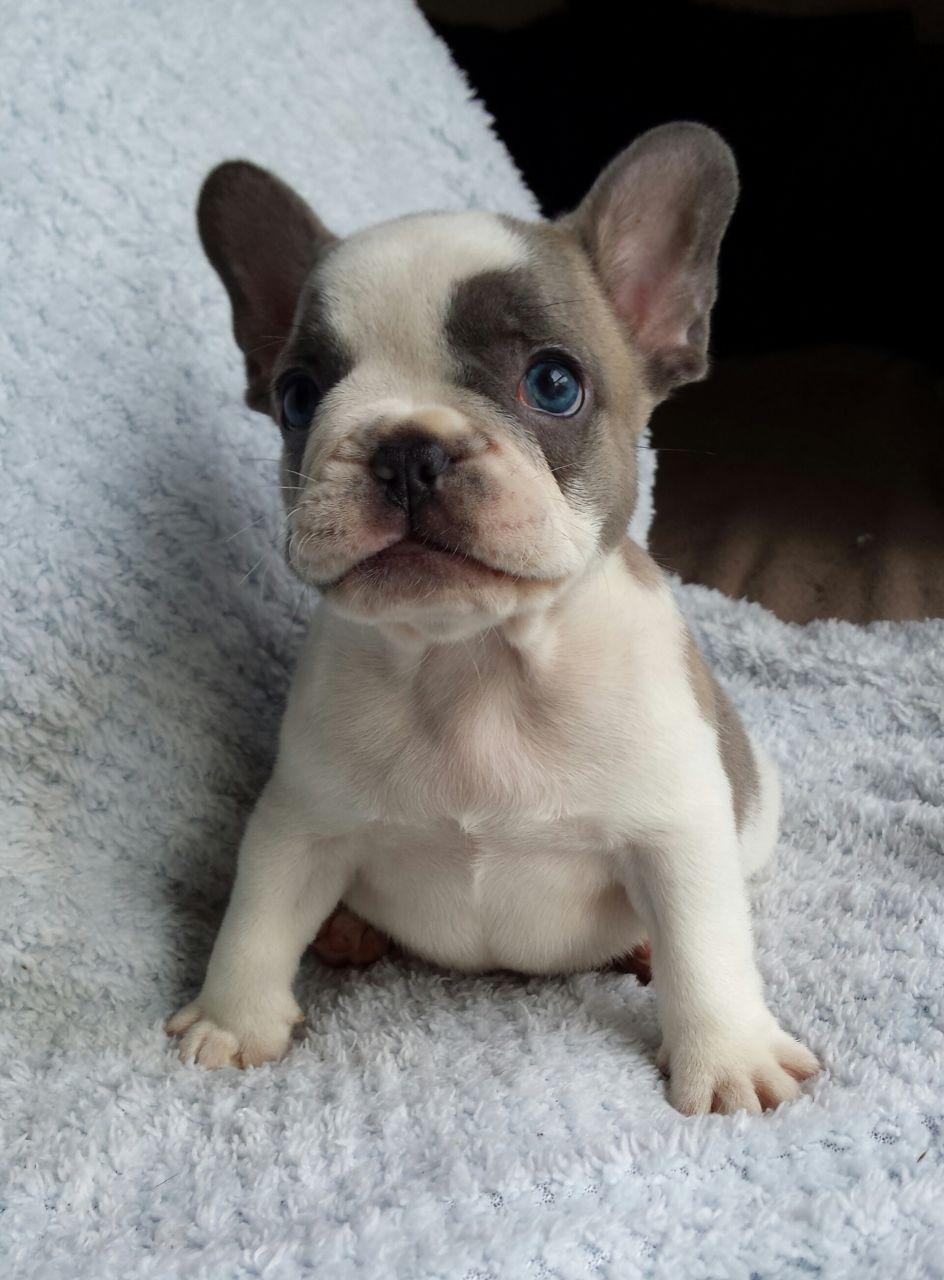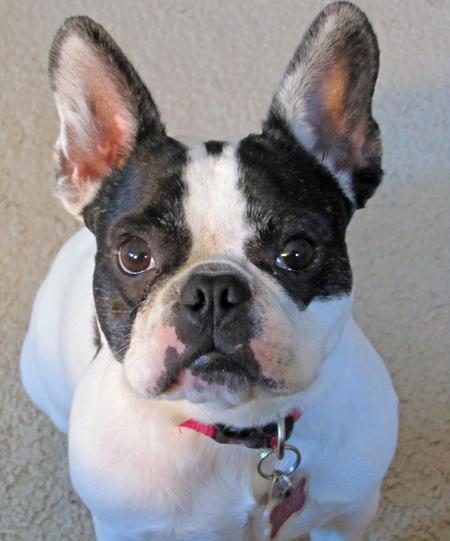The first image is the image on the left, the second image is the image on the right. Considering the images on both sides, is "A dog is wearing a collar." valid? Answer yes or no. Yes. The first image is the image on the left, the second image is the image on the right. For the images shown, is this caption "At least one dog is wearing a collar." true? Answer yes or no. Yes. 